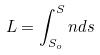Convert formula to latex. <formula><loc_0><loc_0><loc_500><loc_500>L = \int _ { S _ { o } } ^ { S } n d s</formula> 